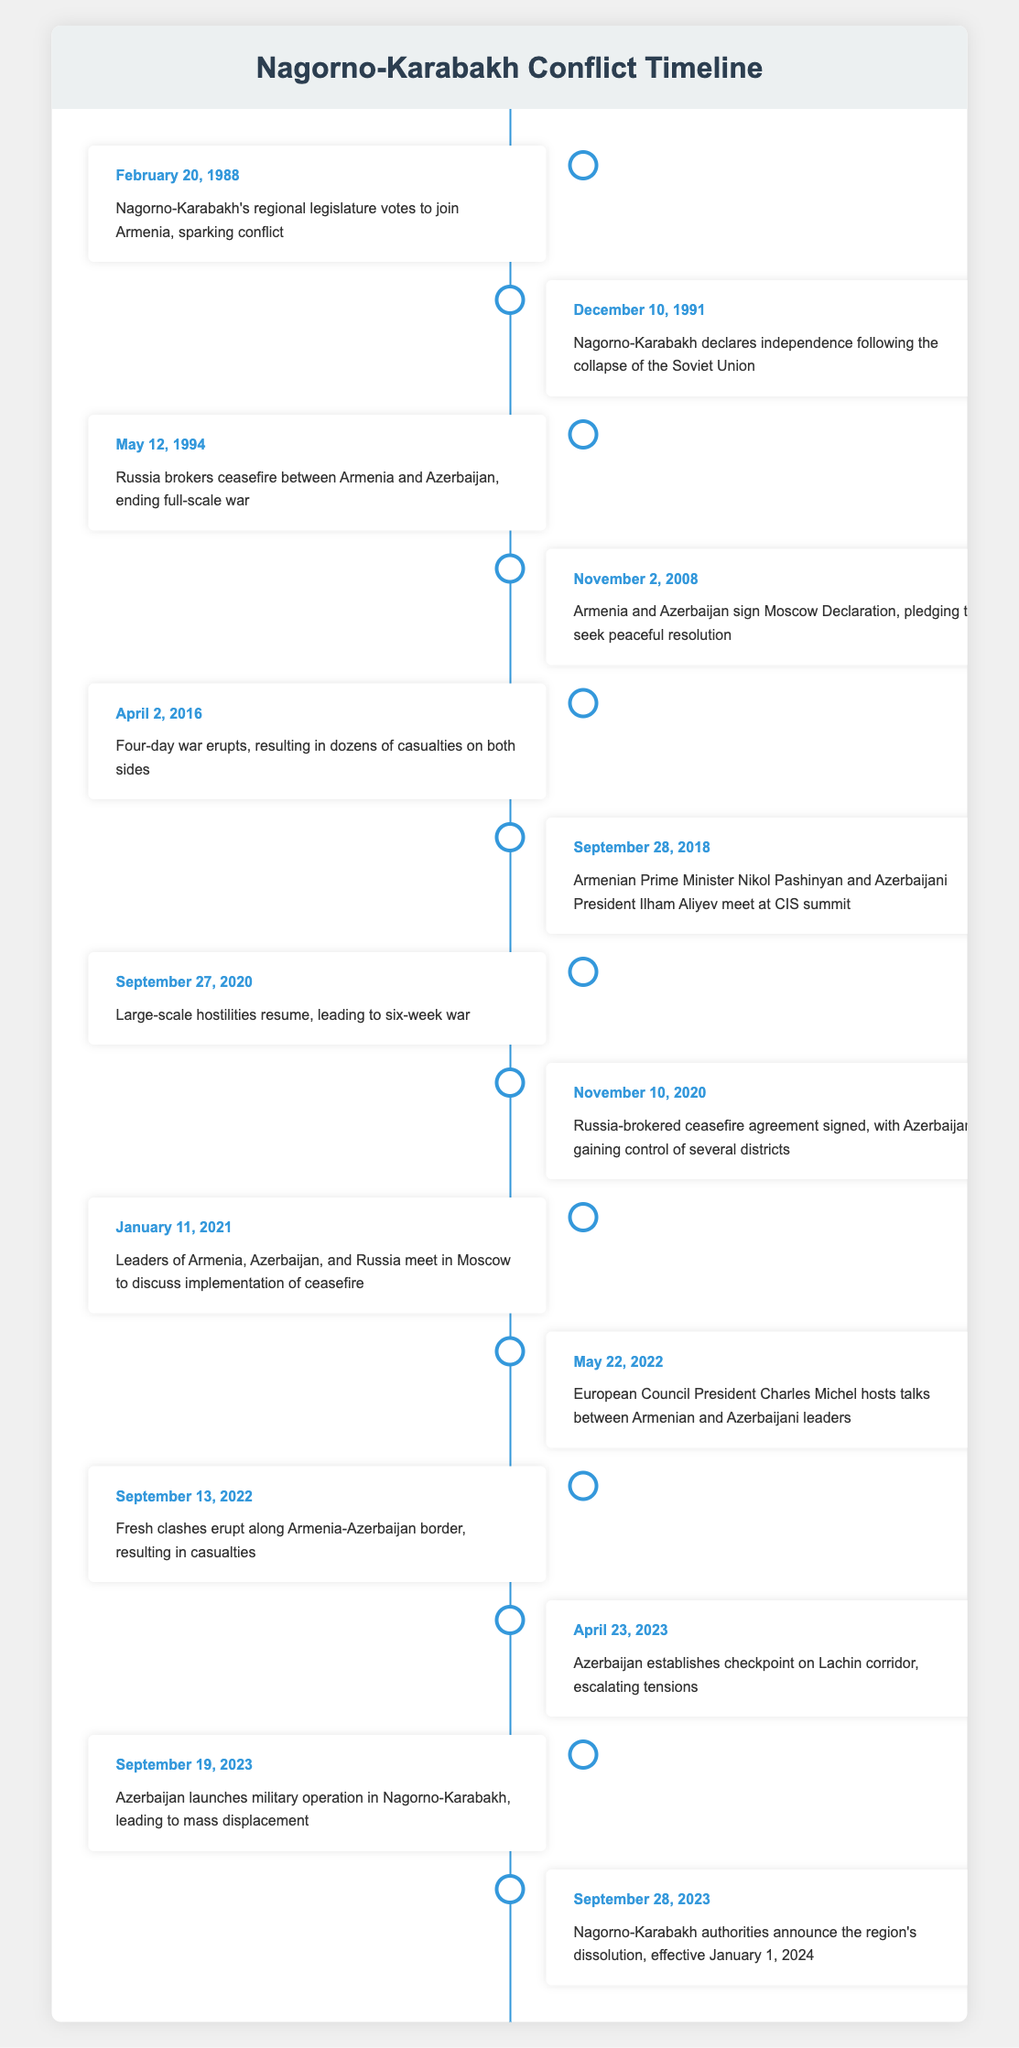What event happened on September 27, 2020? The table shows that on September 27, 2020, large-scale hostilities resumed, leading to a six-week war.
Answer: Large-scale hostilities resumed, leading to six-week war What was the consequence of the ceasefire agreement signed on November 10, 2020? According to the table, the ceasefire agreement signed on November 10, 2020, resulted in Azerbaijan gaining control of several districts.
Answer: Azerbaijan gained control of several districts How many significant developments occurred before the year 2000? By counting the events listed before the year 2000, there are four significant developments: February 20, 1988; December 10, 1991; May 12, 1994; and November 2, 2008.
Answer: Four significant developments Did Armenia and Azerbaijan ever pledge to seek a peaceful resolution in this timeline? Yes, the table indicates that Armenia and Azerbaijan signed the Moscow Declaration on November 2, 2008, pledging to seek a peaceful resolution.
Answer: Yes What is the difference in years between Nagorno-Karabakh's declaration of independence and the signing of the ceasefire agreement? The declaration of independence was on December 10, 1991, and the ceasefire agreement was on May 12, 1994. The difference is about two years and five months.
Answer: Approximately 2.5 years What was one of the outcomes of the April 23, 2023 event? The table states that on April 23, 2023, Azerbaijan established a checkpoint on the Lachin corridor, escalating tensions.
Answer: Tensions escalated How many clashes or conflicts were reported between 2016 and 2022 according to the table? Events reported in that timeframe include the four-day war in April 2016, clashes in September 2022, and various other significant events. Thus, there are three notable conflicts or escalations.
Answer: Three What major change was announced by Nagorno-Karabakh authorities on September 28, 2023? The authorities announced the region's dissolution, effective January 1, 2024.
Answer: The region's dissolution 